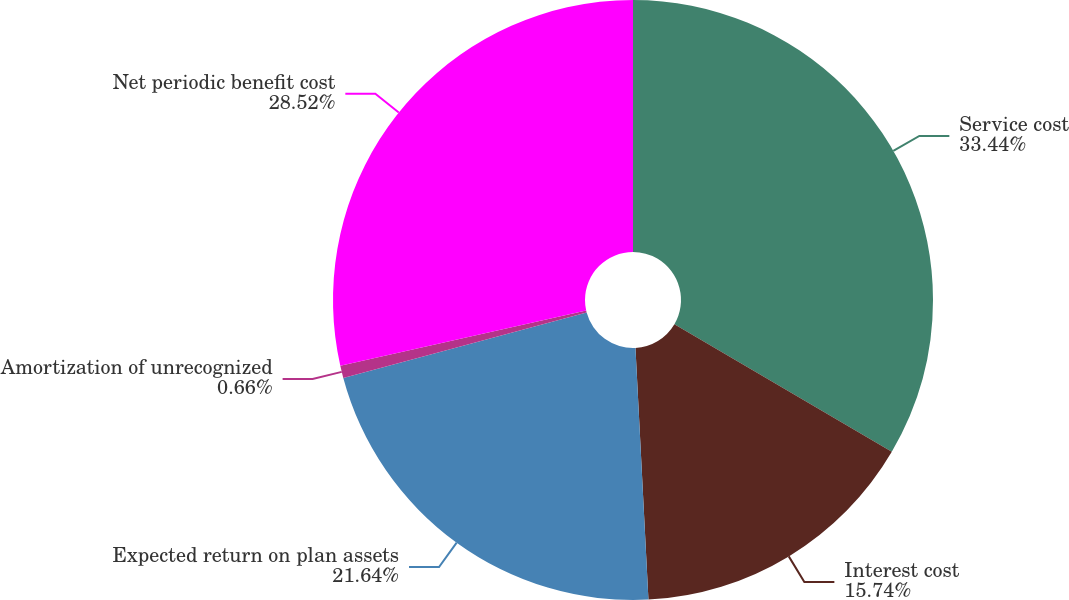<chart> <loc_0><loc_0><loc_500><loc_500><pie_chart><fcel>Service cost<fcel>Interest cost<fcel>Expected return on plan assets<fcel>Amortization of unrecognized<fcel>Net periodic benefit cost<nl><fcel>33.44%<fcel>15.74%<fcel>21.64%<fcel>0.66%<fcel>28.52%<nl></chart> 